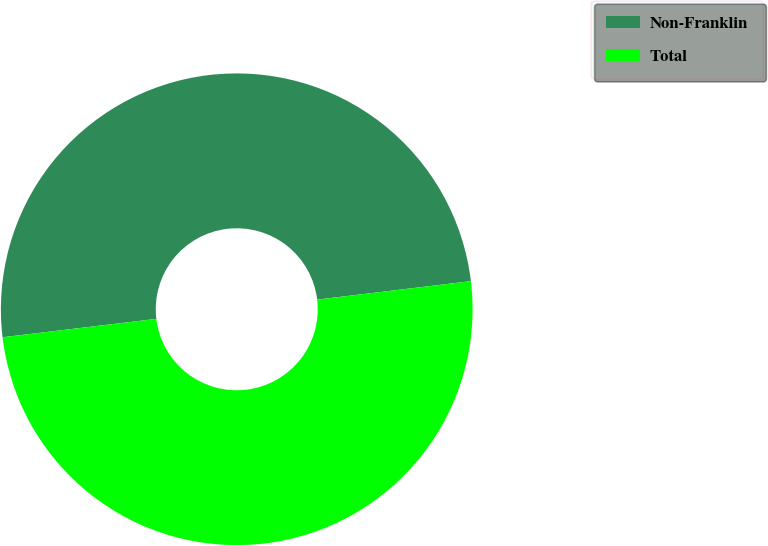Convert chart. <chart><loc_0><loc_0><loc_500><loc_500><pie_chart><fcel>Non-Franklin<fcel>Total<nl><fcel>49.99%<fcel>50.01%<nl></chart> 